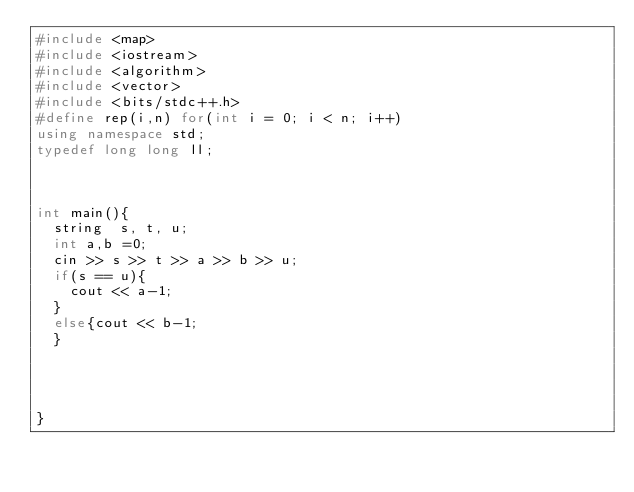<code> <loc_0><loc_0><loc_500><loc_500><_C++_>#include <map>
#include <iostream>
#include <algorithm>
#include <vector>
#include <bits/stdc++.h>
#define rep(i,n) for(int i = 0; i < n; i++)
using namespace std;
typedef long long ll;



int main(){
  string  s, t, u;
  int a,b =0;
  cin >> s >> t >> a >> b >> u;
  if(s == u){
    cout << a-1;
  }
  else{cout << b-1;
  }




}</code> 